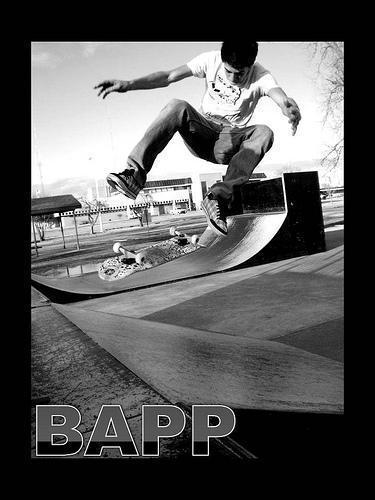World skate is the head controller of which sport?
Make your selection and explain in format: 'Answer: answer
Rationale: rationale.'
Options: Surfing, swimming, skiing, skating. Answer: skating.
Rationale: A person is skateboarding and world skate refers to skateboarding. 